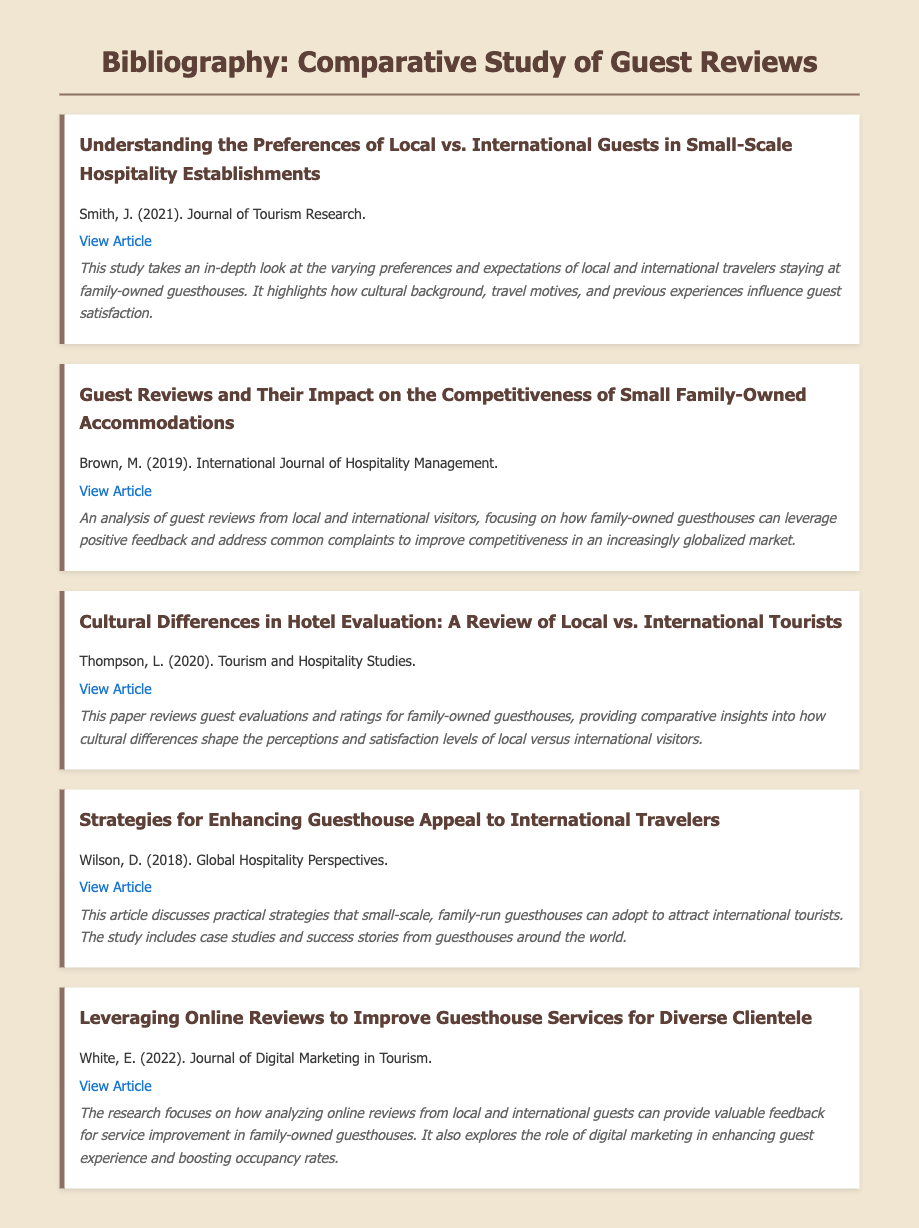what is the title of the first article? The title of the first article is listed beneath the author's name in the document.
Answer: Understanding the Preferences of Local vs. International Guests in Small-Scale Hospitality Establishments who is the author of the article published in 2022? The author's name is provided next to the publication year in the document.
Answer: White, E how many articles are cited in the bibliography? The total number of articles is determined by counting the individual citation blocks present in the document.
Answer: 5 which journal published the article focusing on guest reviews' impact? The journal name is usually stated next to the author's name and publication year.
Answer: International Journal of Hospitality Management what year was the article about cultural differences in hotel evaluation published? The publication year is clearly stated with each article citation in the document.
Answer: 2020 which article discusses strategies for enhancing guesthouse appeal? The title of the article can be found in the respective citation section within the document.
Answer: Strategies for Enhancing Guesthouse Appeal to International Travelers what common theme is addressed in the bibliography? The overall focus of the articles can be inferred from their titles and abstracts.
Answer: Guest reviews and cultural differences who is the author of the article that was published in 2019? The information is provided in the citation section, where the author's name accompanies the article details.
Answer: Brown, M 